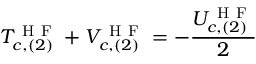<formula> <loc_0><loc_0><loc_500><loc_500>T _ { c , ( 2 ) } ^ { H F } + V _ { c , ( 2 ) } ^ { H F } = - \frac { U _ { c , ( 2 ) } ^ { H F } } { 2 }</formula> 